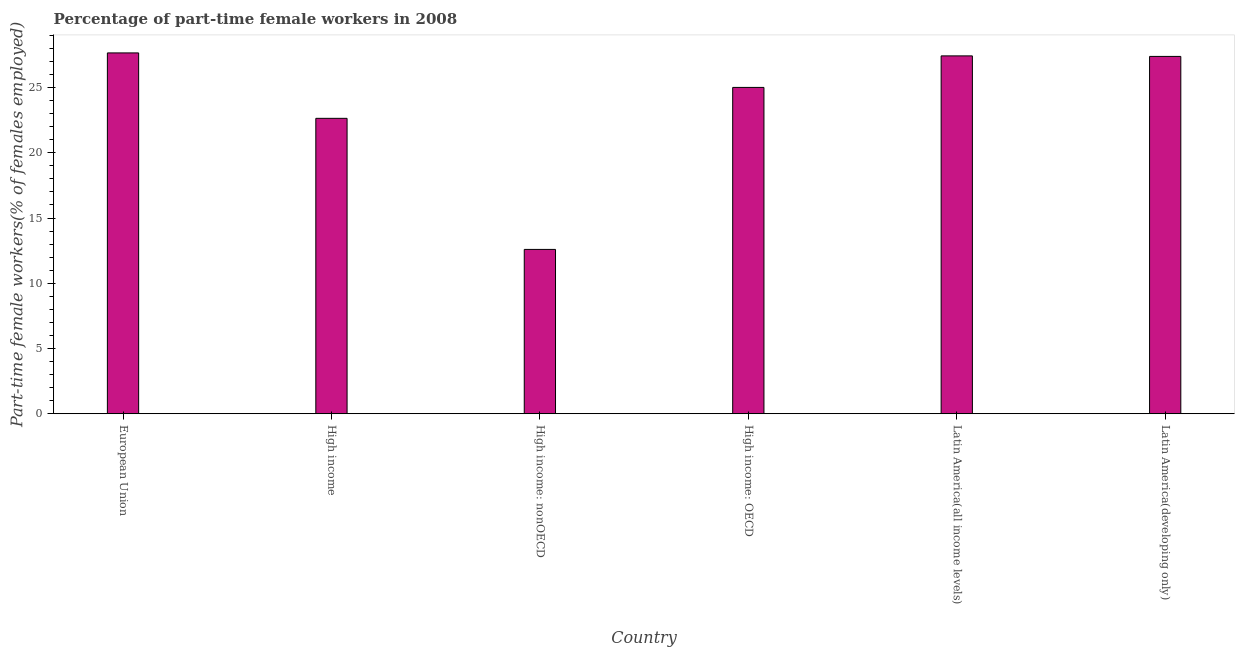Does the graph contain any zero values?
Give a very brief answer. No. Does the graph contain grids?
Your response must be concise. No. What is the title of the graph?
Keep it short and to the point. Percentage of part-time female workers in 2008. What is the label or title of the Y-axis?
Make the answer very short. Part-time female workers(% of females employed). What is the percentage of part-time female workers in Latin America(developing only)?
Your answer should be very brief. 27.38. Across all countries, what is the maximum percentage of part-time female workers?
Offer a very short reply. 27.65. Across all countries, what is the minimum percentage of part-time female workers?
Ensure brevity in your answer.  12.59. In which country was the percentage of part-time female workers maximum?
Your answer should be compact. European Union. In which country was the percentage of part-time female workers minimum?
Keep it short and to the point. High income: nonOECD. What is the sum of the percentage of part-time female workers?
Ensure brevity in your answer.  142.7. What is the difference between the percentage of part-time female workers in High income and Latin America(all income levels)?
Your response must be concise. -4.79. What is the average percentage of part-time female workers per country?
Provide a succinct answer. 23.78. What is the median percentage of part-time female workers?
Offer a very short reply. 26.2. In how many countries, is the percentage of part-time female workers greater than 12 %?
Your answer should be compact. 6. What is the ratio of the percentage of part-time female workers in European Union to that in Latin America(all income levels)?
Offer a very short reply. 1.01. Is the percentage of part-time female workers in European Union less than that in High income: nonOECD?
Your answer should be compact. No. What is the difference between the highest and the second highest percentage of part-time female workers?
Provide a short and direct response. 0.23. Is the sum of the percentage of part-time female workers in High income: OECD and Latin America(all income levels) greater than the maximum percentage of part-time female workers across all countries?
Your answer should be very brief. Yes. What is the difference between the highest and the lowest percentage of part-time female workers?
Make the answer very short. 15.06. How many bars are there?
Give a very brief answer. 6. How many countries are there in the graph?
Your answer should be very brief. 6. What is the difference between two consecutive major ticks on the Y-axis?
Your response must be concise. 5. What is the Part-time female workers(% of females employed) in European Union?
Give a very brief answer. 27.65. What is the Part-time female workers(% of females employed) of High income?
Give a very brief answer. 22.64. What is the Part-time female workers(% of females employed) in High income: nonOECD?
Provide a succinct answer. 12.59. What is the Part-time female workers(% of females employed) in High income: OECD?
Provide a succinct answer. 25.01. What is the Part-time female workers(% of females employed) in Latin America(all income levels)?
Your response must be concise. 27.42. What is the Part-time female workers(% of females employed) of Latin America(developing only)?
Offer a terse response. 27.38. What is the difference between the Part-time female workers(% of females employed) in European Union and High income?
Provide a short and direct response. 5.01. What is the difference between the Part-time female workers(% of females employed) in European Union and High income: nonOECD?
Provide a succinct answer. 15.06. What is the difference between the Part-time female workers(% of females employed) in European Union and High income: OECD?
Give a very brief answer. 2.64. What is the difference between the Part-time female workers(% of females employed) in European Union and Latin America(all income levels)?
Provide a short and direct response. 0.23. What is the difference between the Part-time female workers(% of females employed) in European Union and Latin America(developing only)?
Give a very brief answer. 0.27. What is the difference between the Part-time female workers(% of females employed) in High income and High income: nonOECD?
Your answer should be very brief. 10.05. What is the difference between the Part-time female workers(% of females employed) in High income and High income: OECD?
Keep it short and to the point. -2.37. What is the difference between the Part-time female workers(% of females employed) in High income and Latin America(all income levels)?
Your answer should be very brief. -4.79. What is the difference between the Part-time female workers(% of females employed) in High income and Latin America(developing only)?
Offer a very short reply. -4.75. What is the difference between the Part-time female workers(% of females employed) in High income: nonOECD and High income: OECD?
Keep it short and to the point. -12.41. What is the difference between the Part-time female workers(% of females employed) in High income: nonOECD and Latin America(all income levels)?
Provide a short and direct response. -14.83. What is the difference between the Part-time female workers(% of females employed) in High income: nonOECD and Latin America(developing only)?
Offer a very short reply. -14.79. What is the difference between the Part-time female workers(% of females employed) in High income: OECD and Latin America(all income levels)?
Keep it short and to the point. -2.42. What is the difference between the Part-time female workers(% of females employed) in High income: OECD and Latin America(developing only)?
Ensure brevity in your answer.  -2.38. What is the difference between the Part-time female workers(% of females employed) in Latin America(all income levels) and Latin America(developing only)?
Offer a terse response. 0.04. What is the ratio of the Part-time female workers(% of females employed) in European Union to that in High income?
Offer a terse response. 1.22. What is the ratio of the Part-time female workers(% of females employed) in European Union to that in High income: nonOECD?
Your answer should be very brief. 2.2. What is the ratio of the Part-time female workers(% of females employed) in European Union to that in High income: OECD?
Your answer should be compact. 1.11. What is the ratio of the Part-time female workers(% of females employed) in High income to that in High income: nonOECD?
Make the answer very short. 1.8. What is the ratio of the Part-time female workers(% of females employed) in High income to that in High income: OECD?
Offer a terse response. 0.91. What is the ratio of the Part-time female workers(% of females employed) in High income to that in Latin America(all income levels)?
Your answer should be compact. 0.82. What is the ratio of the Part-time female workers(% of females employed) in High income to that in Latin America(developing only)?
Offer a terse response. 0.83. What is the ratio of the Part-time female workers(% of females employed) in High income: nonOECD to that in High income: OECD?
Offer a terse response. 0.5. What is the ratio of the Part-time female workers(% of females employed) in High income: nonOECD to that in Latin America(all income levels)?
Your response must be concise. 0.46. What is the ratio of the Part-time female workers(% of females employed) in High income: nonOECD to that in Latin America(developing only)?
Give a very brief answer. 0.46. What is the ratio of the Part-time female workers(% of females employed) in High income: OECD to that in Latin America(all income levels)?
Keep it short and to the point. 0.91. What is the ratio of the Part-time female workers(% of females employed) in High income: OECD to that in Latin America(developing only)?
Your answer should be compact. 0.91. 